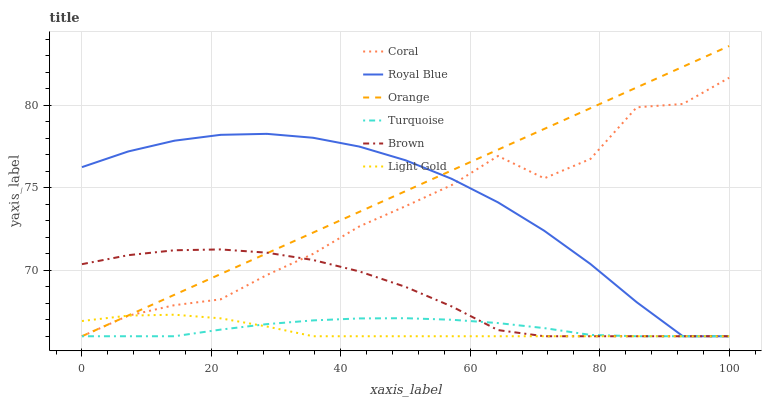Does Light Gold have the minimum area under the curve?
Answer yes or no. Yes. Does Orange have the maximum area under the curve?
Answer yes or no. Yes. Does Turquoise have the minimum area under the curve?
Answer yes or no. No. Does Turquoise have the maximum area under the curve?
Answer yes or no. No. Is Orange the smoothest?
Answer yes or no. Yes. Is Coral the roughest?
Answer yes or no. Yes. Is Turquoise the smoothest?
Answer yes or no. No. Is Turquoise the roughest?
Answer yes or no. No. Does Brown have the lowest value?
Answer yes or no. Yes. Does Orange have the highest value?
Answer yes or no. Yes. Does Coral have the highest value?
Answer yes or no. No. Does Coral intersect Light Gold?
Answer yes or no. Yes. Is Coral less than Light Gold?
Answer yes or no. No. Is Coral greater than Light Gold?
Answer yes or no. No. 